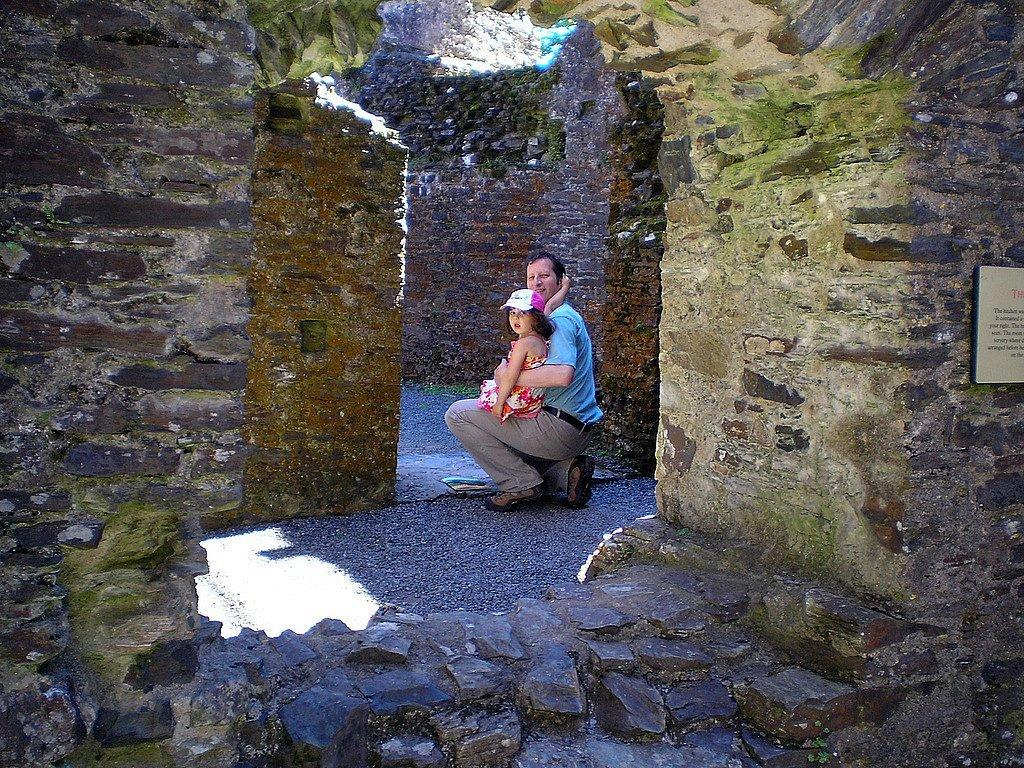What is the person in the image doing with the girl? The person is holding the girl in the image. What type of background can be seen in the image? There are brick walls visible in the image. What type of wound can be seen on the girl's leg in the image? There is no wound visible on the girl's leg in the image. What discovery was made by the person holding the girl in the image? There is no indication of a discovery being made in the image. 